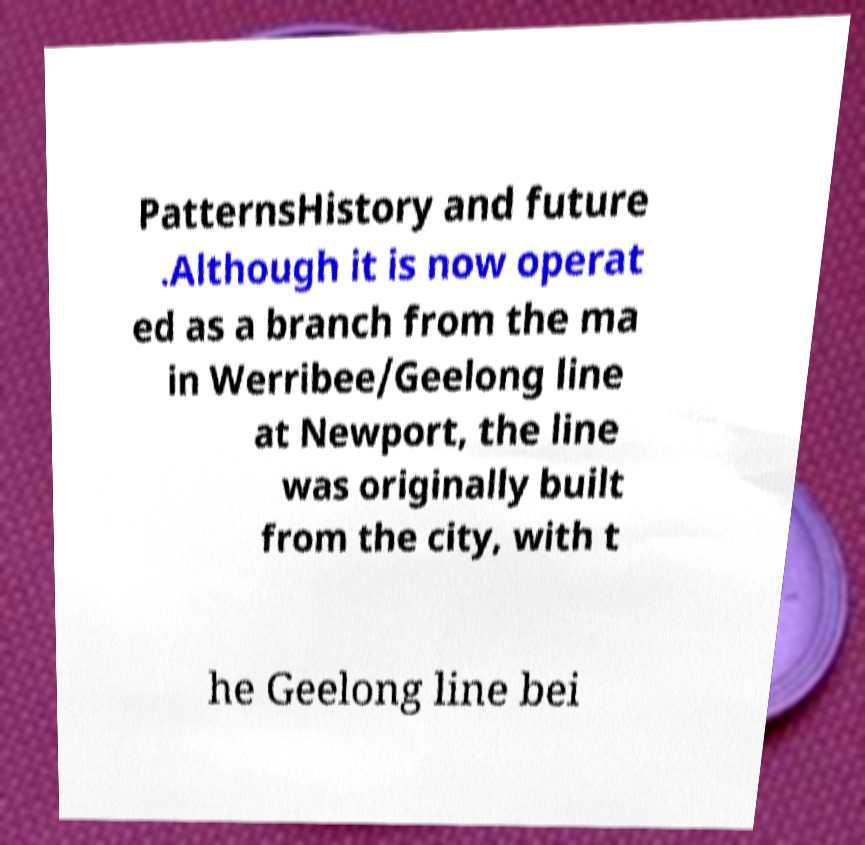There's text embedded in this image that I need extracted. Can you transcribe it verbatim? PatternsHistory and future .Although it is now operat ed as a branch from the ma in Werribee/Geelong line at Newport, the line was originally built from the city, with t he Geelong line bei 